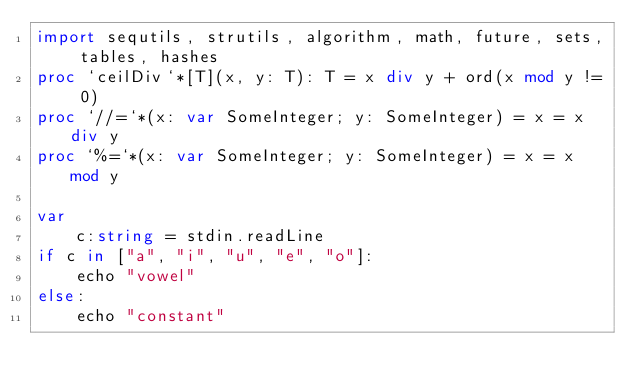<code> <loc_0><loc_0><loc_500><loc_500><_Nim_>import sequtils, strutils, algorithm, math, future, sets, tables, hashes
proc `ceilDiv`*[T](x, y: T): T = x div y + ord(x mod y != 0)
proc `//=`*(x: var SomeInteger; y: SomeInteger) = x = x div y
proc `%=`*(x: var SomeInteger; y: SomeInteger) = x = x mod y

var 
    c:string = stdin.readLine
if c in ["a", "i", "u", "e", "o"]:
    echo "vowel"
else:
    echo "constant"</code> 